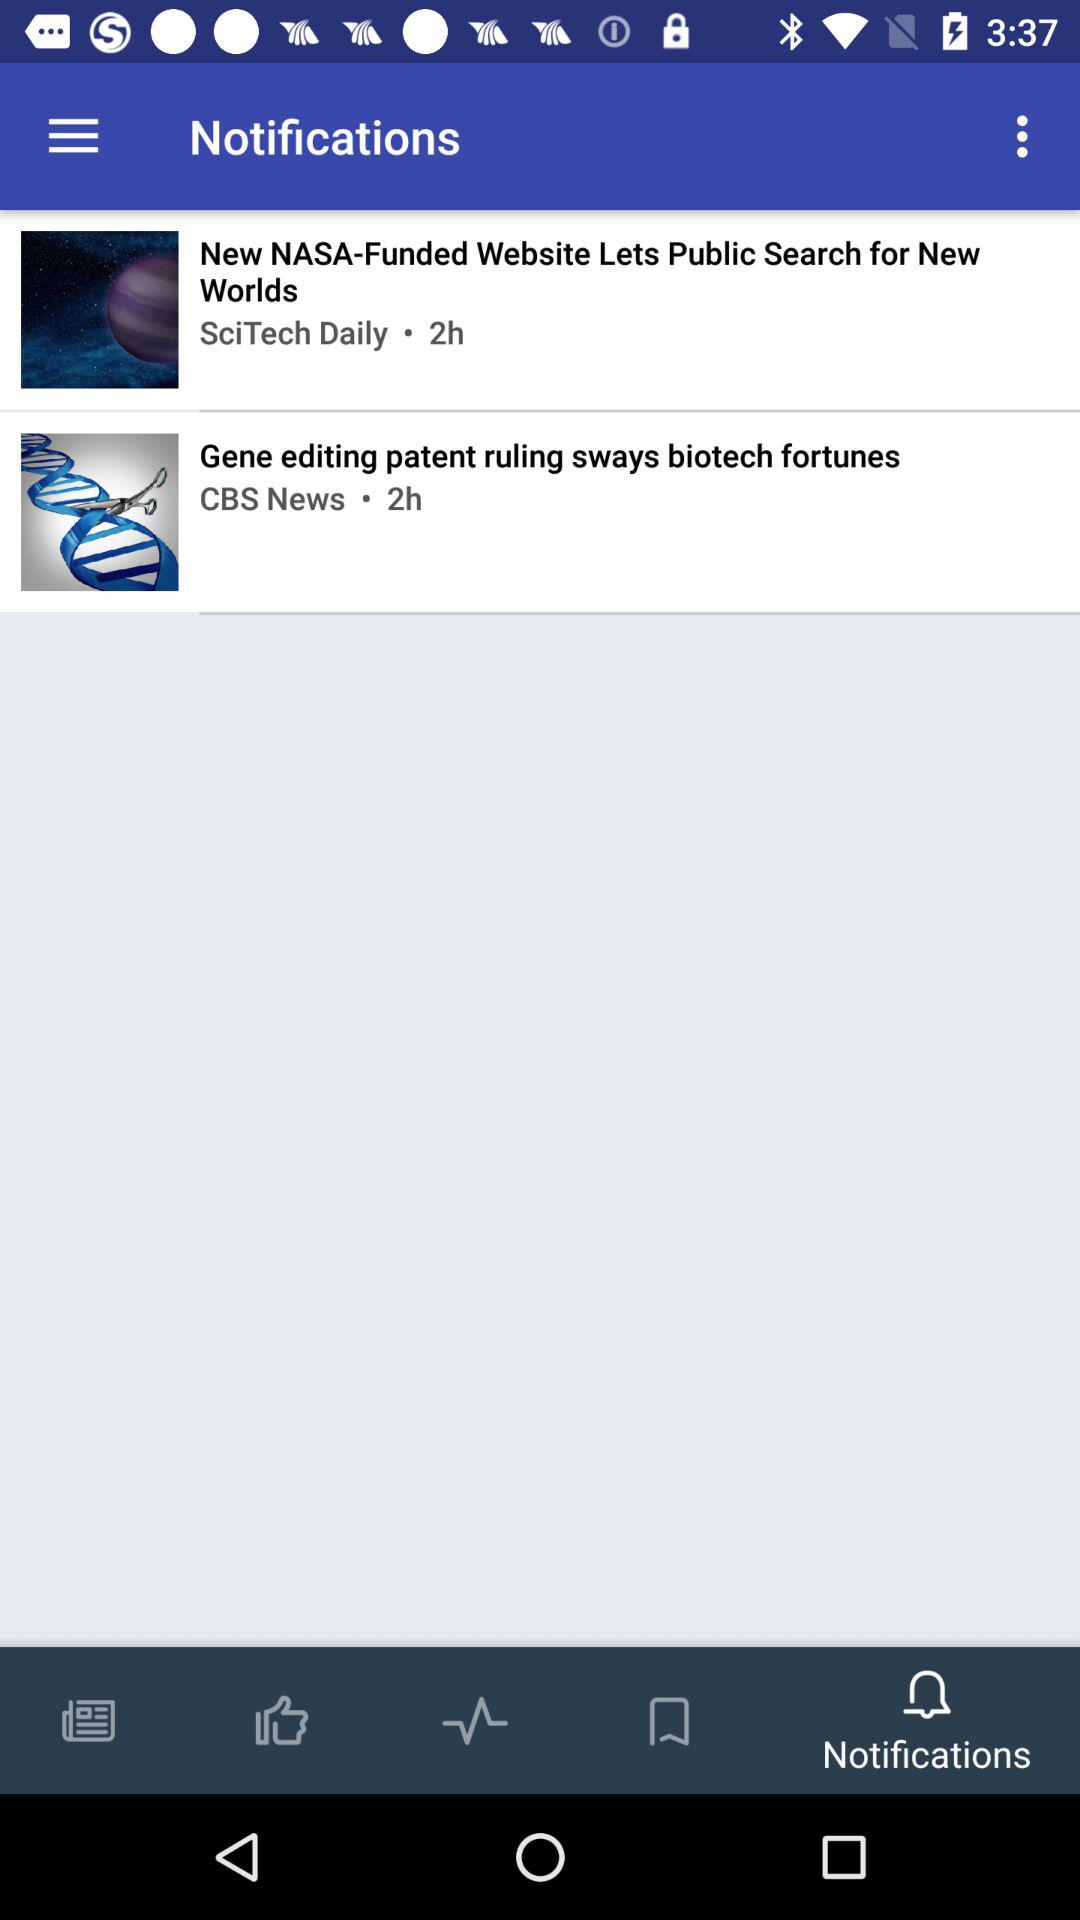What are the notifications? The notifications are "New NASA-Funded Website Lets Public Search for New Worlds" and "Gene editing patent ruling sways biotech fortunes". 